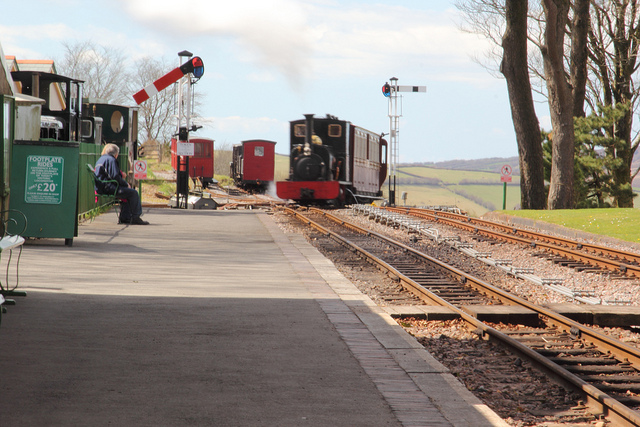Please transcribe the text information in this image. 20 